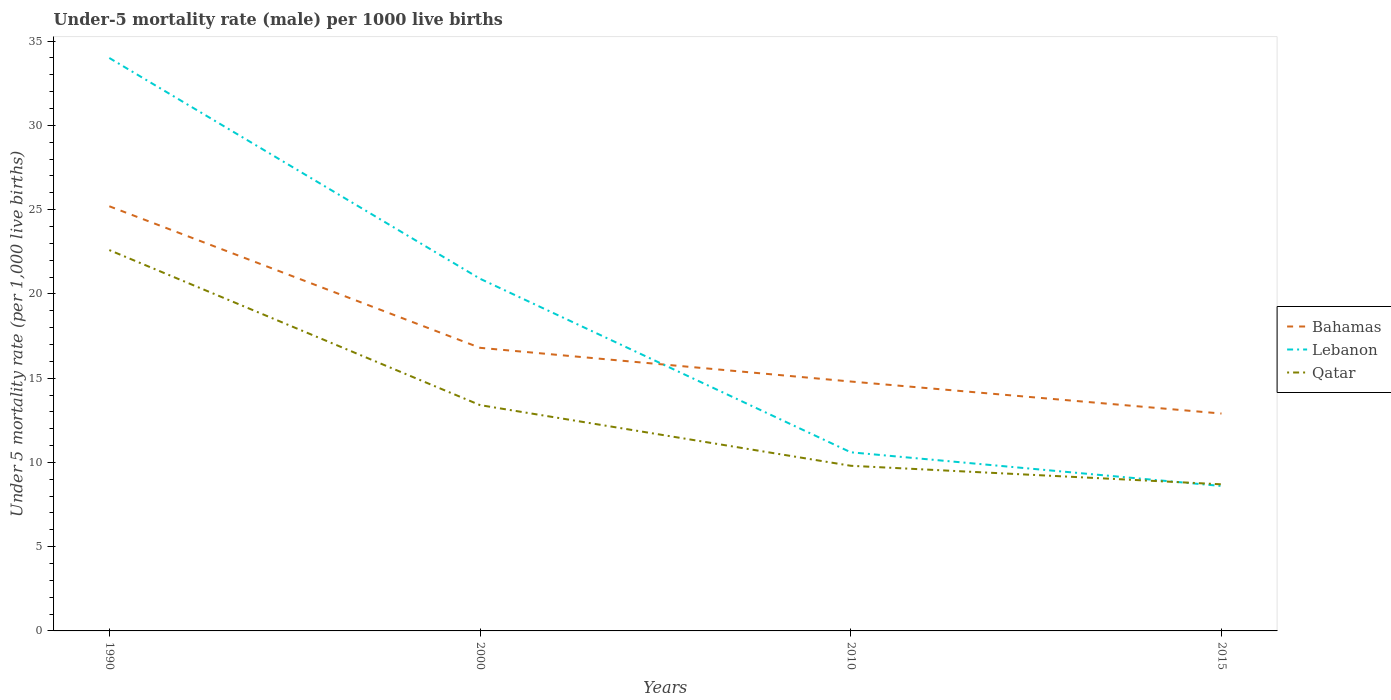How many different coloured lines are there?
Provide a succinct answer. 3. Does the line corresponding to Lebanon intersect with the line corresponding to Bahamas?
Offer a terse response. Yes. Is the number of lines equal to the number of legend labels?
Offer a terse response. Yes. Across all years, what is the maximum under-five mortality rate in Lebanon?
Ensure brevity in your answer.  8.6. In which year was the under-five mortality rate in Qatar maximum?
Make the answer very short. 2015. What is the total under-five mortality rate in Qatar in the graph?
Ensure brevity in your answer.  4.7. What is the difference between the highest and the second highest under-five mortality rate in Bahamas?
Provide a succinct answer. 12.3. What is the difference between the highest and the lowest under-five mortality rate in Qatar?
Provide a short and direct response. 1. Is the under-five mortality rate in Qatar strictly greater than the under-five mortality rate in Lebanon over the years?
Give a very brief answer. No. What is the difference between two consecutive major ticks on the Y-axis?
Give a very brief answer. 5. Are the values on the major ticks of Y-axis written in scientific E-notation?
Your answer should be very brief. No. Does the graph contain any zero values?
Provide a short and direct response. No. Does the graph contain grids?
Give a very brief answer. No. Where does the legend appear in the graph?
Provide a short and direct response. Center right. How are the legend labels stacked?
Offer a terse response. Vertical. What is the title of the graph?
Your answer should be compact. Under-5 mortality rate (male) per 1000 live births. Does "Seychelles" appear as one of the legend labels in the graph?
Make the answer very short. No. What is the label or title of the Y-axis?
Your response must be concise. Under 5 mortality rate (per 1,0 live births). What is the Under 5 mortality rate (per 1,000 live births) in Bahamas in 1990?
Keep it short and to the point. 25.2. What is the Under 5 mortality rate (per 1,000 live births) in Qatar in 1990?
Offer a very short reply. 22.6. What is the Under 5 mortality rate (per 1,000 live births) of Bahamas in 2000?
Your answer should be compact. 16.8. What is the Under 5 mortality rate (per 1,000 live births) of Lebanon in 2000?
Provide a succinct answer. 20.9. What is the Under 5 mortality rate (per 1,000 live births) of Lebanon in 2010?
Give a very brief answer. 10.6. What is the Under 5 mortality rate (per 1,000 live births) in Bahamas in 2015?
Provide a short and direct response. 12.9. What is the Under 5 mortality rate (per 1,000 live births) of Qatar in 2015?
Ensure brevity in your answer.  8.7. Across all years, what is the maximum Under 5 mortality rate (per 1,000 live births) of Bahamas?
Your answer should be compact. 25.2. Across all years, what is the maximum Under 5 mortality rate (per 1,000 live births) of Qatar?
Make the answer very short. 22.6. Across all years, what is the minimum Under 5 mortality rate (per 1,000 live births) in Qatar?
Offer a terse response. 8.7. What is the total Under 5 mortality rate (per 1,000 live births) in Bahamas in the graph?
Provide a short and direct response. 69.7. What is the total Under 5 mortality rate (per 1,000 live births) in Lebanon in the graph?
Provide a succinct answer. 74.1. What is the total Under 5 mortality rate (per 1,000 live births) of Qatar in the graph?
Your answer should be compact. 54.5. What is the difference between the Under 5 mortality rate (per 1,000 live births) in Lebanon in 1990 and that in 2010?
Your response must be concise. 23.4. What is the difference between the Under 5 mortality rate (per 1,000 live births) in Lebanon in 1990 and that in 2015?
Ensure brevity in your answer.  25.4. What is the difference between the Under 5 mortality rate (per 1,000 live births) of Qatar in 1990 and that in 2015?
Give a very brief answer. 13.9. What is the difference between the Under 5 mortality rate (per 1,000 live births) of Qatar in 2000 and that in 2010?
Make the answer very short. 3.6. What is the difference between the Under 5 mortality rate (per 1,000 live births) in Bahamas in 1990 and the Under 5 mortality rate (per 1,000 live births) in Lebanon in 2000?
Provide a short and direct response. 4.3. What is the difference between the Under 5 mortality rate (per 1,000 live births) in Bahamas in 1990 and the Under 5 mortality rate (per 1,000 live births) in Qatar in 2000?
Provide a short and direct response. 11.8. What is the difference between the Under 5 mortality rate (per 1,000 live births) of Lebanon in 1990 and the Under 5 mortality rate (per 1,000 live births) of Qatar in 2000?
Your answer should be very brief. 20.6. What is the difference between the Under 5 mortality rate (per 1,000 live births) of Bahamas in 1990 and the Under 5 mortality rate (per 1,000 live births) of Qatar in 2010?
Provide a succinct answer. 15.4. What is the difference between the Under 5 mortality rate (per 1,000 live births) in Lebanon in 1990 and the Under 5 mortality rate (per 1,000 live births) in Qatar in 2010?
Provide a short and direct response. 24.2. What is the difference between the Under 5 mortality rate (per 1,000 live births) of Lebanon in 1990 and the Under 5 mortality rate (per 1,000 live births) of Qatar in 2015?
Make the answer very short. 25.3. What is the difference between the Under 5 mortality rate (per 1,000 live births) in Bahamas in 2000 and the Under 5 mortality rate (per 1,000 live births) in Lebanon in 2010?
Keep it short and to the point. 6.2. What is the difference between the Under 5 mortality rate (per 1,000 live births) of Bahamas in 2000 and the Under 5 mortality rate (per 1,000 live births) of Qatar in 2010?
Your response must be concise. 7. What is the difference between the Under 5 mortality rate (per 1,000 live births) in Lebanon in 2000 and the Under 5 mortality rate (per 1,000 live births) in Qatar in 2010?
Your response must be concise. 11.1. What is the difference between the Under 5 mortality rate (per 1,000 live births) in Bahamas in 2000 and the Under 5 mortality rate (per 1,000 live births) in Qatar in 2015?
Your answer should be compact. 8.1. What is the difference between the Under 5 mortality rate (per 1,000 live births) in Bahamas in 2010 and the Under 5 mortality rate (per 1,000 live births) in Lebanon in 2015?
Make the answer very short. 6.2. What is the difference between the Under 5 mortality rate (per 1,000 live births) in Lebanon in 2010 and the Under 5 mortality rate (per 1,000 live births) in Qatar in 2015?
Give a very brief answer. 1.9. What is the average Under 5 mortality rate (per 1,000 live births) of Bahamas per year?
Your answer should be compact. 17.43. What is the average Under 5 mortality rate (per 1,000 live births) of Lebanon per year?
Make the answer very short. 18.52. What is the average Under 5 mortality rate (per 1,000 live births) in Qatar per year?
Your answer should be very brief. 13.62. In the year 1990, what is the difference between the Under 5 mortality rate (per 1,000 live births) of Bahamas and Under 5 mortality rate (per 1,000 live births) of Qatar?
Your response must be concise. 2.6. In the year 2010, what is the difference between the Under 5 mortality rate (per 1,000 live births) in Bahamas and Under 5 mortality rate (per 1,000 live births) in Lebanon?
Your response must be concise. 4.2. In the year 2015, what is the difference between the Under 5 mortality rate (per 1,000 live births) in Bahamas and Under 5 mortality rate (per 1,000 live births) in Lebanon?
Offer a very short reply. 4.3. In the year 2015, what is the difference between the Under 5 mortality rate (per 1,000 live births) in Lebanon and Under 5 mortality rate (per 1,000 live births) in Qatar?
Provide a succinct answer. -0.1. What is the ratio of the Under 5 mortality rate (per 1,000 live births) in Lebanon in 1990 to that in 2000?
Ensure brevity in your answer.  1.63. What is the ratio of the Under 5 mortality rate (per 1,000 live births) in Qatar in 1990 to that in 2000?
Offer a terse response. 1.69. What is the ratio of the Under 5 mortality rate (per 1,000 live births) of Bahamas in 1990 to that in 2010?
Offer a very short reply. 1.7. What is the ratio of the Under 5 mortality rate (per 1,000 live births) of Lebanon in 1990 to that in 2010?
Your answer should be very brief. 3.21. What is the ratio of the Under 5 mortality rate (per 1,000 live births) of Qatar in 1990 to that in 2010?
Your answer should be very brief. 2.31. What is the ratio of the Under 5 mortality rate (per 1,000 live births) of Bahamas in 1990 to that in 2015?
Offer a terse response. 1.95. What is the ratio of the Under 5 mortality rate (per 1,000 live births) of Lebanon in 1990 to that in 2015?
Make the answer very short. 3.95. What is the ratio of the Under 5 mortality rate (per 1,000 live births) in Qatar in 1990 to that in 2015?
Offer a terse response. 2.6. What is the ratio of the Under 5 mortality rate (per 1,000 live births) in Bahamas in 2000 to that in 2010?
Ensure brevity in your answer.  1.14. What is the ratio of the Under 5 mortality rate (per 1,000 live births) of Lebanon in 2000 to that in 2010?
Offer a terse response. 1.97. What is the ratio of the Under 5 mortality rate (per 1,000 live births) in Qatar in 2000 to that in 2010?
Keep it short and to the point. 1.37. What is the ratio of the Under 5 mortality rate (per 1,000 live births) in Bahamas in 2000 to that in 2015?
Ensure brevity in your answer.  1.3. What is the ratio of the Under 5 mortality rate (per 1,000 live births) in Lebanon in 2000 to that in 2015?
Provide a succinct answer. 2.43. What is the ratio of the Under 5 mortality rate (per 1,000 live births) of Qatar in 2000 to that in 2015?
Ensure brevity in your answer.  1.54. What is the ratio of the Under 5 mortality rate (per 1,000 live births) of Bahamas in 2010 to that in 2015?
Your answer should be compact. 1.15. What is the ratio of the Under 5 mortality rate (per 1,000 live births) of Lebanon in 2010 to that in 2015?
Give a very brief answer. 1.23. What is the ratio of the Under 5 mortality rate (per 1,000 live births) in Qatar in 2010 to that in 2015?
Ensure brevity in your answer.  1.13. What is the difference between the highest and the second highest Under 5 mortality rate (per 1,000 live births) in Lebanon?
Your answer should be very brief. 13.1. What is the difference between the highest and the second highest Under 5 mortality rate (per 1,000 live births) in Qatar?
Provide a succinct answer. 9.2. What is the difference between the highest and the lowest Under 5 mortality rate (per 1,000 live births) of Lebanon?
Keep it short and to the point. 25.4. What is the difference between the highest and the lowest Under 5 mortality rate (per 1,000 live births) of Qatar?
Offer a very short reply. 13.9. 